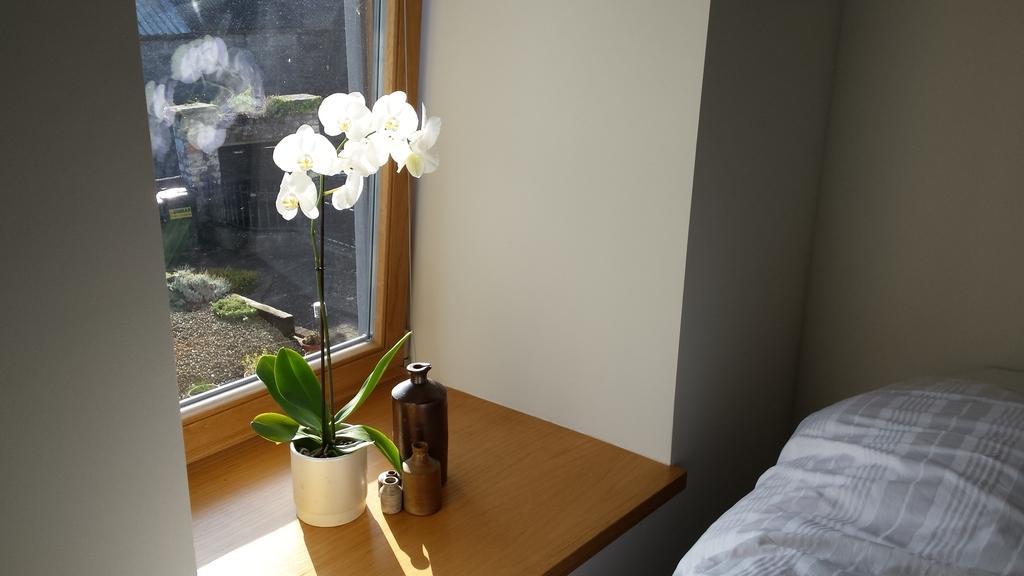Describe this image in one or two sentences. On the right side of the image there is a bed. There is a wall. In the center of the image there is a wooden board. On top of it there is a flower pot and a few other objects. In the background of the image there is a glass window through which we can see a metal fence, plants and a wall. 